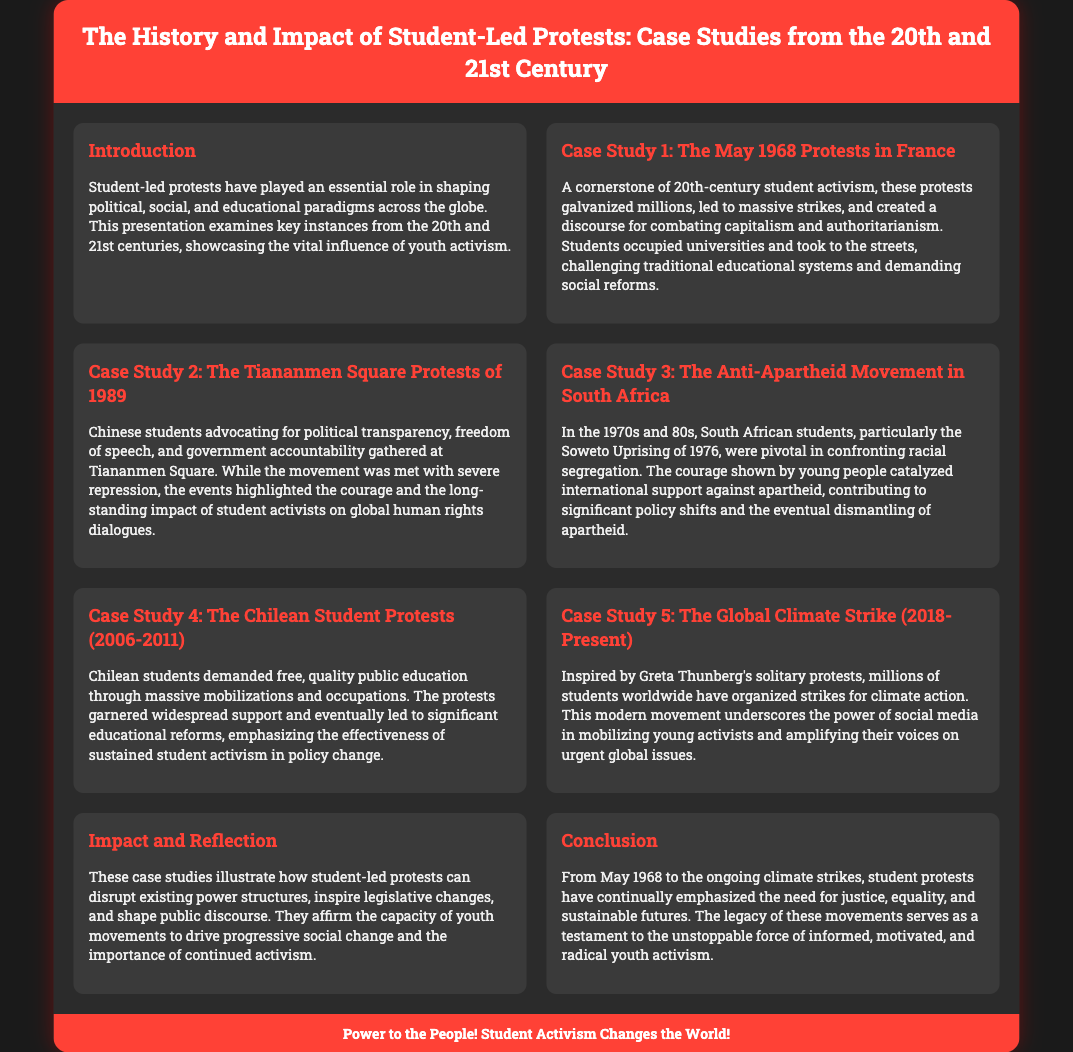What is the title of the presentation? The title of the presentation is prominently displayed at the top and states the focus on student-led protests and their impact.
Answer: The History and Impact of Student-Led Protests: Case Studies from the 20th and 21st Century What was a key demand of the students during the Tiananmen Square protests? The document mentions specific demands made by students, with a focus on political transparency and freedom of speech.
Answer: Political transparency In what year did the Soweto Uprising occur? The document specifically refers to the Soweto Uprising in the context of the anti-apartheid movement in the 1970s and 80s.
Answer: 1976 Which global movement was inspired by Greta Thunberg? The document describes a modern movement sparked by her actions, specifically mentioning global participation for climate action.
Answer: The Global Climate Strike What impact did student-led protests have according to the presentation? The document discusses multiple effects of these protests, including disrupting power structures and shaping public discourse.
Answer: Disrupt existing power structures What was the significant educational reform outcome from the Chilean student protests? The document indicates that the protests led to important policy changes in education, specifically demanding free and quality public education.
Answer: Educational reforms How did the May 1968 protests challenge traditional systems? The presentation outlines the occupation of universities and streets to confront and challenge existing societal systems.
Answer: Challenging traditional educational systems What do youth movements affirm according to the conclusion? The conclusion reflects on the outcomes of youth protests, asserting the strong influence of these movements on progressive change.
Answer: The capacity of youth movements to drive progressive social change 